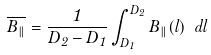<formula> <loc_0><loc_0><loc_500><loc_500>\overline { B _ { \| } } = \frac { 1 } { D _ { 2 } - D _ { 1 } } \int _ { D _ { 1 } } ^ { D _ { 2 } } B _ { \| } ( l ) \ d l</formula> 